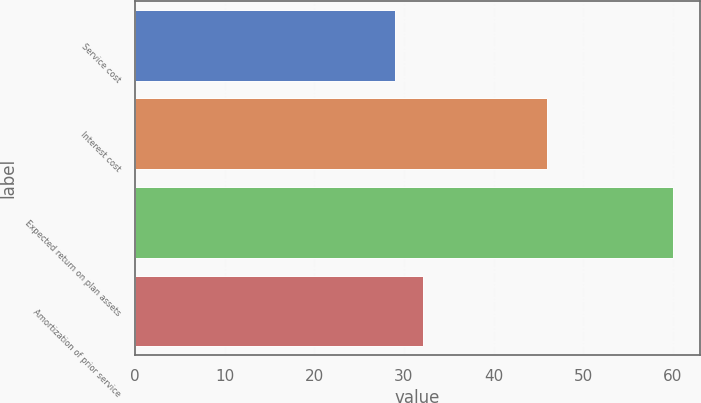<chart> <loc_0><loc_0><loc_500><loc_500><bar_chart><fcel>Service cost<fcel>Interest cost<fcel>Expected return on plan assets<fcel>Amortization of prior service<nl><fcel>29<fcel>46<fcel>60<fcel>32.1<nl></chart> 